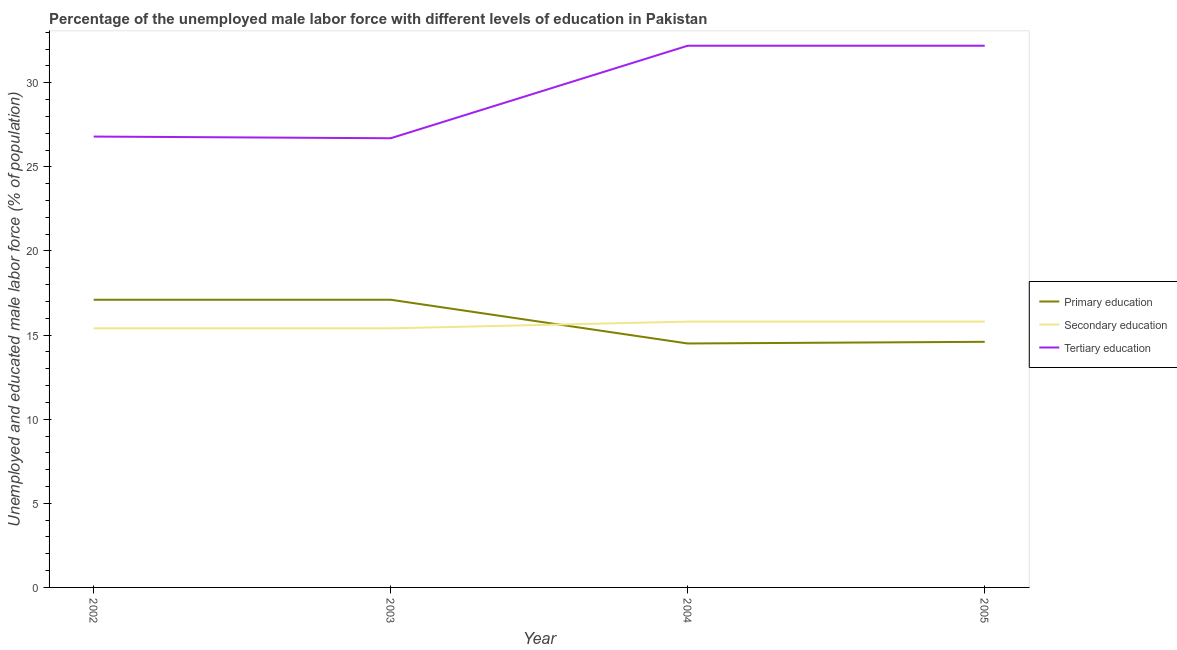How many different coloured lines are there?
Your answer should be very brief. 3. Is the number of lines equal to the number of legend labels?
Offer a very short reply. Yes. What is the percentage of male labor force who received primary education in 2004?
Give a very brief answer. 14.5. Across all years, what is the maximum percentage of male labor force who received primary education?
Your response must be concise. 17.1. Across all years, what is the minimum percentage of male labor force who received tertiary education?
Keep it short and to the point. 26.7. What is the total percentage of male labor force who received secondary education in the graph?
Offer a very short reply. 62.4. What is the difference between the percentage of male labor force who received secondary education in 2002 and that in 2005?
Your answer should be compact. -0.4. What is the difference between the percentage of male labor force who received secondary education in 2005 and the percentage of male labor force who received primary education in 2003?
Keep it short and to the point. -1.3. What is the average percentage of male labor force who received tertiary education per year?
Keep it short and to the point. 29.48. In the year 2005, what is the difference between the percentage of male labor force who received primary education and percentage of male labor force who received tertiary education?
Offer a very short reply. -17.6. In how many years, is the percentage of male labor force who received primary education greater than 12 %?
Make the answer very short. 4. What is the ratio of the percentage of male labor force who received tertiary education in 2003 to that in 2005?
Your answer should be very brief. 0.83. Is the percentage of male labor force who received tertiary education in 2002 less than that in 2004?
Offer a very short reply. Yes. What is the difference between the highest and the lowest percentage of male labor force who received tertiary education?
Your response must be concise. 5.5. In how many years, is the percentage of male labor force who received tertiary education greater than the average percentage of male labor force who received tertiary education taken over all years?
Provide a short and direct response. 2. Is the sum of the percentage of male labor force who received primary education in 2002 and 2004 greater than the maximum percentage of male labor force who received tertiary education across all years?
Your answer should be compact. No. Is the percentage of male labor force who received secondary education strictly greater than the percentage of male labor force who received tertiary education over the years?
Your answer should be very brief. No. Is the percentage of male labor force who received tertiary education strictly less than the percentage of male labor force who received secondary education over the years?
Your answer should be compact. No. How many lines are there?
Give a very brief answer. 3. How many years are there in the graph?
Keep it short and to the point. 4. Are the values on the major ticks of Y-axis written in scientific E-notation?
Offer a very short reply. No. Does the graph contain any zero values?
Give a very brief answer. No. How are the legend labels stacked?
Your answer should be very brief. Vertical. What is the title of the graph?
Give a very brief answer. Percentage of the unemployed male labor force with different levels of education in Pakistan. Does "Resident buildings and public services" appear as one of the legend labels in the graph?
Offer a very short reply. No. What is the label or title of the X-axis?
Your answer should be very brief. Year. What is the label or title of the Y-axis?
Ensure brevity in your answer.  Unemployed and educated male labor force (% of population). What is the Unemployed and educated male labor force (% of population) in Primary education in 2002?
Your answer should be compact. 17.1. What is the Unemployed and educated male labor force (% of population) of Secondary education in 2002?
Ensure brevity in your answer.  15.4. What is the Unemployed and educated male labor force (% of population) in Tertiary education in 2002?
Make the answer very short. 26.8. What is the Unemployed and educated male labor force (% of population) of Primary education in 2003?
Offer a terse response. 17.1. What is the Unemployed and educated male labor force (% of population) in Secondary education in 2003?
Give a very brief answer. 15.4. What is the Unemployed and educated male labor force (% of population) of Tertiary education in 2003?
Your answer should be very brief. 26.7. What is the Unemployed and educated male labor force (% of population) of Primary education in 2004?
Provide a succinct answer. 14.5. What is the Unemployed and educated male labor force (% of population) of Secondary education in 2004?
Ensure brevity in your answer.  15.8. What is the Unemployed and educated male labor force (% of population) in Tertiary education in 2004?
Your answer should be very brief. 32.2. What is the Unemployed and educated male labor force (% of population) in Primary education in 2005?
Offer a very short reply. 14.6. What is the Unemployed and educated male labor force (% of population) in Secondary education in 2005?
Provide a short and direct response. 15.8. What is the Unemployed and educated male labor force (% of population) of Tertiary education in 2005?
Your answer should be compact. 32.2. Across all years, what is the maximum Unemployed and educated male labor force (% of population) in Primary education?
Provide a short and direct response. 17.1. Across all years, what is the maximum Unemployed and educated male labor force (% of population) in Secondary education?
Ensure brevity in your answer.  15.8. Across all years, what is the maximum Unemployed and educated male labor force (% of population) in Tertiary education?
Keep it short and to the point. 32.2. Across all years, what is the minimum Unemployed and educated male labor force (% of population) of Primary education?
Keep it short and to the point. 14.5. Across all years, what is the minimum Unemployed and educated male labor force (% of population) in Secondary education?
Your answer should be very brief. 15.4. Across all years, what is the minimum Unemployed and educated male labor force (% of population) in Tertiary education?
Give a very brief answer. 26.7. What is the total Unemployed and educated male labor force (% of population) in Primary education in the graph?
Ensure brevity in your answer.  63.3. What is the total Unemployed and educated male labor force (% of population) of Secondary education in the graph?
Offer a very short reply. 62.4. What is the total Unemployed and educated male labor force (% of population) of Tertiary education in the graph?
Keep it short and to the point. 117.9. What is the difference between the Unemployed and educated male labor force (% of population) in Secondary education in 2002 and that in 2003?
Offer a very short reply. 0. What is the difference between the Unemployed and educated male labor force (% of population) of Tertiary education in 2002 and that in 2003?
Your answer should be compact. 0.1. What is the difference between the Unemployed and educated male labor force (% of population) in Primary education in 2002 and that in 2005?
Ensure brevity in your answer.  2.5. What is the difference between the Unemployed and educated male labor force (% of population) of Secondary education in 2002 and that in 2005?
Provide a short and direct response. -0.4. What is the difference between the Unemployed and educated male labor force (% of population) of Tertiary education in 2002 and that in 2005?
Make the answer very short. -5.4. What is the difference between the Unemployed and educated male labor force (% of population) in Secondary education in 2003 and that in 2004?
Ensure brevity in your answer.  -0.4. What is the difference between the Unemployed and educated male labor force (% of population) in Tertiary education in 2003 and that in 2004?
Provide a short and direct response. -5.5. What is the difference between the Unemployed and educated male labor force (% of population) of Primary education in 2003 and that in 2005?
Provide a short and direct response. 2.5. What is the difference between the Unemployed and educated male labor force (% of population) in Secondary education in 2003 and that in 2005?
Give a very brief answer. -0.4. What is the difference between the Unemployed and educated male labor force (% of population) of Tertiary education in 2003 and that in 2005?
Provide a short and direct response. -5.5. What is the difference between the Unemployed and educated male labor force (% of population) of Secondary education in 2004 and that in 2005?
Give a very brief answer. 0. What is the difference between the Unemployed and educated male labor force (% of population) in Primary education in 2002 and the Unemployed and educated male labor force (% of population) in Tertiary education in 2003?
Your response must be concise. -9.6. What is the difference between the Unemployed and educated male labor force (% of population) of Primary education in 2002 and the Unemployed and educated male labor force (% of population) of Secondary education in 2004?
Provide a succinct answer. 1.3. What is the difference between the Unemployed and educated male labor force (% of population) in Primary education in 2002 and the Unemployed and educated male labor force (% of population) in Tertiary education in 2004?
Provide a short and direct response. -15.1. What is the difference between the Unemployed and educated male labor force (% of population) in Secondary education in 2002 and the Unemployed and educated male labor force (% of population) in Tertiary education in 2004?
Provide a short and direct response. -16.8. What is the difference between the Unemployed and educated male labor force (% of population) of Primary education in 2002 and the Unemployed and educated male labor force (% of population) of Tertiary education in 2005?
Provide a succinct answer. -15.1. What is the difference between the Unemployed and educated male labor force (% of population) in Secondary education in 2002 and the Unemployed and educated male labor force (% of population) in Tertiary education in 2005?
Provide a succinct answer. -16.8. What is the difference between the Unemployed and educated male labor force (% of population) of Primary education in 2003 and the Unemployed and educated male labor force (% of population) of Secondary education in 2004?
Make the answer very short. 1.3. What is the difference between the Unemployed and educated male labor force (% of population) of Primary education in 2003 and the Unemployed and educated male labor force (% of population) of Tertiary education in 2004?
Provide a short and direct response. -15.1. What is the difference between the Unemployed and educated male labor force (% of population) in Secondary education in 2003 and the Unemployed and educated male labor force (% of population) in Tertiary education in 2004?
Offer a very short reply. -16.8. What is the difference between the Unemployed and educated male labor force (% of population) in Primary education in 2003 and the Unemployed and educated male labor force (% of population) in Secondary education in 2005?
Your answer should be very brief. 1.3. What is the difference between the Unemployed and educated male labor force (% of population) in Primary education in 2003 and the Unemployed and educated male labor force (% of population) in Tertiary education in 2005?
Provide a succinct answer. -15.1. What is the difference between the Unemployed and educated male labor force (% of population) in Secondary education in 2003 and the Unemployed and educated male labor force (% of population) in Tertiary education in 2005?
Your answer should be very brief. -16.8. What is the difference between the Unemployed and educated male labor force (% of population) in Primary education in 2004 and the Unemployed and educated male labor force (% of population) in Secondary education in 2005?
Keep it short and to the point. -1.3. What is the difference between the Unemployed and educated male labor force (% of population) of Primary education in 2004 and the Unemployed and educated male labor force (% of population) of Tertiary education in 2005?
Offer a very short reply. -17.7. What is the difference between the Unemployed and educated male labor force (% of population) of Secondary education in 2004 and the Unemployed and educated male labor force (% of population) of Tertiary education in 2005?
Keep it short and to the point. -16.4. What is the average Unemployed and educated male labor force (% of population) of Primary education per year?
Ensure brevity in your answer.  15.82. What is the average Unemployed and educated male labor force (% of population) in Secondary education per year?
Provide a short and direct response. 15.6. What is the average Unemployed and educated male labor force (% of population) of Tertiary education per year?
Provide a succinct answer. 29.48. In the year 2002, what is the difference between the Unemployed and educated male labor force (% of population) in Primary education and Unemployed and educated male labor force (% of population) in Secondary education?
Your answer should be compact. 1.7. In the year 2002, what is the difference between the Unemployed and educated male labor force (% of population) in Secondary education and Unemployed and educated male labor force (% of population) in Tertiary education?
Your response must be concise. -11.4. In the year 2003, what is the difference between the Unemployed and educated male labor force (% of population) of Primary education and Unemployed and educated male labor force (% of population) of Secondary education?
Offer a terse response. 1.7. In the year 2004, what is the difference between the Unemployed and educated male labor force (% of population) in Primary education and Unemployed and educated male labor force (% of population) in Tertiary education?
Provide a succinct answer. -17.7. In the year 2004, what is the difference between the Unemployed and educated male labor force (% of population) in Secondary education and Unemployed and educated male labor force (% of population) in Tertiary education?
Offer a terse response. -16.4. In the year 2005, what is the difference between the Unemployed and educated male labor force (% of population) in Primary education and Unemployed and educated male labor force (% of population) in Secondary education?
Offer a terse response. -1.2. In the year 2005, what is the difference between the Unemployed and educated male labor force (% of population) of Primary education and Unemployed and educated male labor force (% of population) of Tertiary education?
Your answer should be very brief. -17.6. In the year 2005, what is the difference between the Unemployed and educated male labor force (% of population) in Secondary education and Unemployed and educated male labor force (% of population) in Tertiary education?
Offer a very short reply. -16.4. What is the ratio of the Unemployed and educated male labor force (% of population) in Primary education in 2002 to that in 2003?
Keep it short and to the point. 1. What is the ratio of the Unemployed and educated male labor force (% of population) in Tertiary education in 2002 to that in 2003?
Offer a very short reply. 1. What is the ratio of the Unemployed and educated male labor force (% of population) in Primary education in 2002 to that in 2004?
Offer a terse response. 1.18. What is the ratio of the Unemployed and educated male labor force (% of population) of Secondary education in 2002 to that in 2004?
Your answer should be very brief. 0.97. What is the ratio of the Unemployed and educated male labor force (% of population) of Tertiary education in 2002 to that in 2004?
Your response must be concise. 0.83. What is the ratio of the Unemployed and educated male labor force (% of population) of Primary education in 2002 to that in 2005?
Your answer should be compact. 1.17. What is the ratio of the Unemployed and educated male labor force (% of population) of Secondary education in 2002 to that in 2005?
Give a very brief answer. 0.97. What is the ratio of the Unemployed and educated male labor force (% of population) in Tertiary education in 2002 to that in 2005?
Provide a succinct answer. 0.83. What is the ratio of the Unemployed and educated male labor force (% of population) of Primary education in 2003 to that in 2004?
Your answer should be very brief. 1.18. What is the ratio of the Unemployed and educated male labor force (% of population) of Secondary education in 2003 to that in 2004?
Your answer should be very brief. 0.97. What is the ratio of the Unemployed and educated male labor force (% of population) of Tertiary education in 2003 to that in 2004?
Offer a very short reply. 0.83. What is the ratio of the Unemployed and educated male labor force (% of population) of Primary education in 2003 to that in 2005?
Your answer should be very brief. 1.17. What is the ratio of the Unemployed and educated male labor force (% of population) of Secondary education in 2003 to that in 2005?
Provide a short and direct response. 0.97. What is the ratio of the Unemployed and educated male labor force (% of population) of Tertiary education in 2003 to that in 2005?
Ensure brevity in your answer.  0.83. What is the ratio of the Unemployed and educated male labor force (% of population) in Primary education in 2004 to that in 2005?
Offer a terse response. 0.99. What is the ratio of the Unemployed and educated male labor force (% of population) in Secondary education in 2004 to that in 2005?
Make the answer very short. 1. What is the ratio of the Unemployed and educated male labor force (% of population) of Tertiary education in 2004 to that in 2005?
Ensure brevity in your answer.  1. What is the difference between the highest and the second highest Unemployed and educated male labor force (% of population) in Primary education?
Provide a short and direct response. 0. What is the difference between the highest and the second highest Unemployed and educated male labor force (% of population) of Tertiary education?
Provide a succinct answer. 0. What is the difference between the highest and the lowest Unemployed and educated male labor force (% of population) of Secondary education?
Your response must be concise. 0.4. 